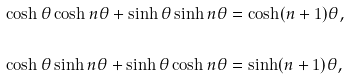Convert formula to latex. <formula><loc_0><loc_0><loc_500><loc_500>\cosh \theta \cosh n \theta + \sinh \theta \sinh n \theta & = \cosh ( n + 1 ) \theta , \\ & \\ \cosh \theta \sinh n \theta + \sinh \theta \cosh n \theta & = \sinh ( n + 1 ) \theta ,</formula> 